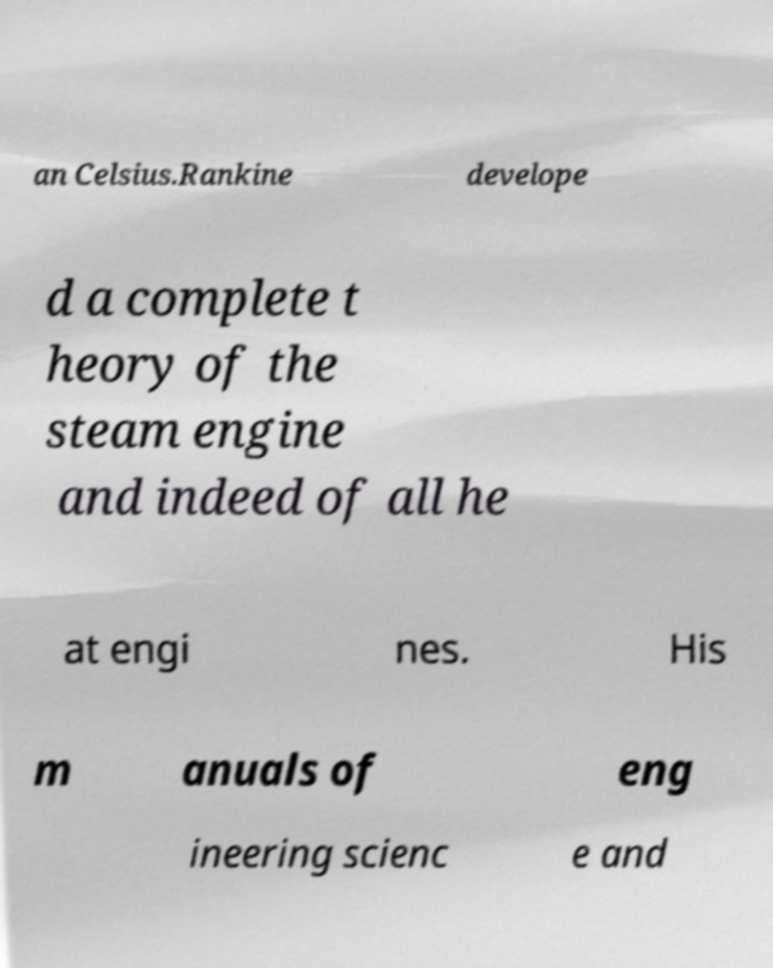Can you read and provide the text displayed in the image?This photo seems to have some interesting text. Can you extract and type it out for me? an Celsius.Rankine develope d a complete t heory of the steam engine and indeed of all he at engi nes. His m anuals of eng ineering scienc e and 